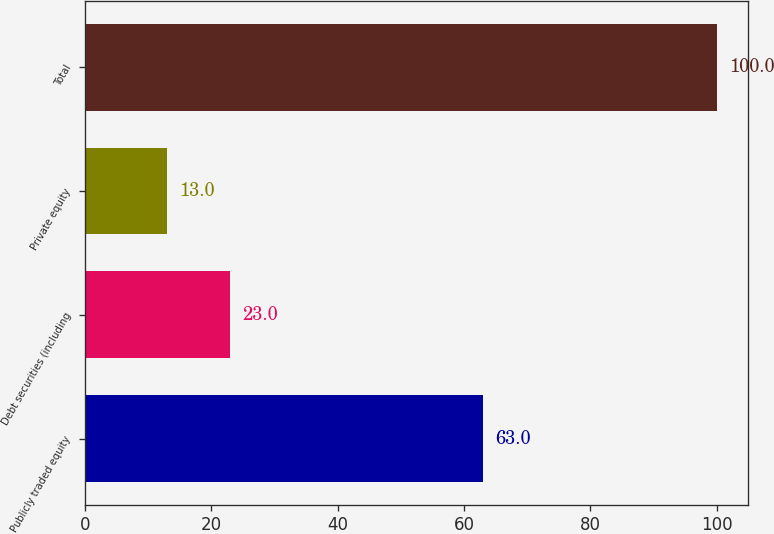Convert chart to OTSL. <chart><loc_0><loc_0><loc_500><loc_500><bar_chart><fcel>Publicly traded equity<fcel>Debt securities (including<fcel>Private equity<fcel>Total<nl><fcel>63<fcel>23<fcel>13<fcel>100<nl></chart> 